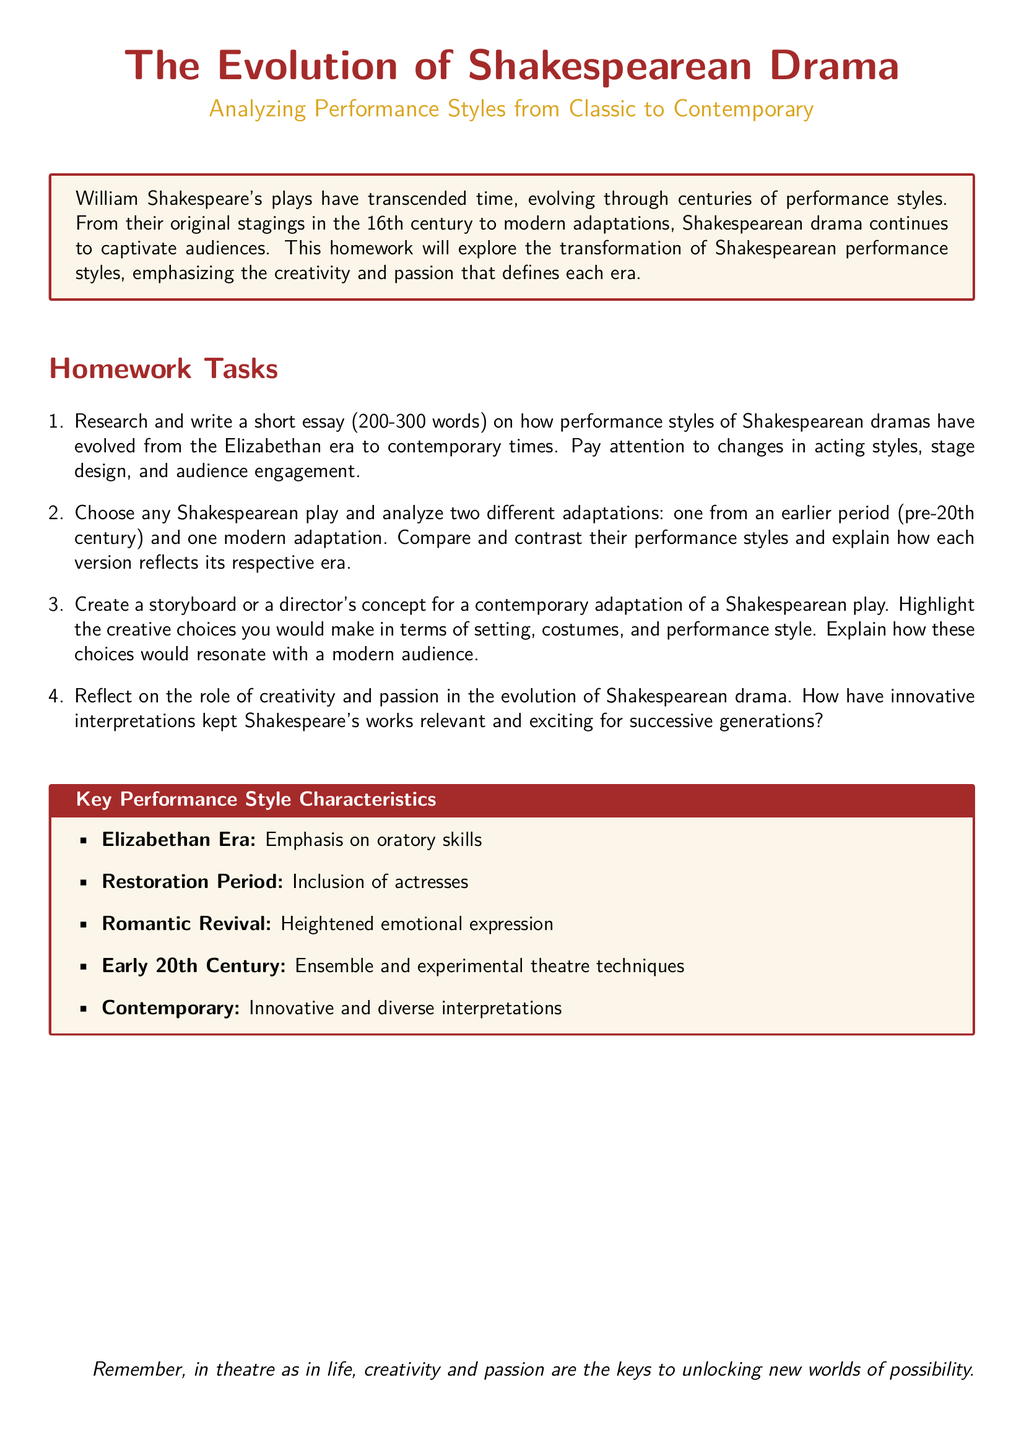What is the main subject of the document? The document focuses on the evolution of Shakespearean drama and its performance styles from classic to contemporary.
Answer: The Evolution of Shakespearean Drama How many homework tasks are listed in the document? The document lists four distinct homework tasks for analysis and creativity.
Answer: Four What is the word count range for the essay task? The document specifies that the essay should be between 200 to 300 words.
Answer: 200-300 words Which era included the first use of actresses in performances? The document states that the Restoration Period was significant for including actresses on stage.
Answer: Restoration Period What is one key performance style characteristic of the Elizabethan Era? The document highlights that the Elizabethan Era emphasized oratory skills in performance.
Answer: Oratory skills What should the storyboard focus on for a contemporary adaptation? The storyboard should highlight creative choices in setting, costumes, and performance style.
Answer: Setting, costumes, and performance style How does the document suggest innovative interpretations affect Shakespeare's relevance? The document implies that innovative interpretations keep Shakespeare's works exciting and relevant for successive generations.
Answer: Keep relevant and exciting What color is used for the heading in the document? The heading is colored in a shade described as theatreRed.
Answer: theatreRed 